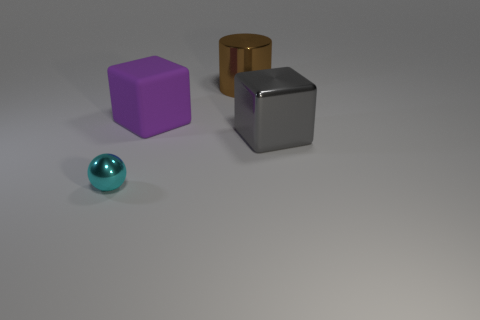Add 3 green rubber balls. How many objects exist? 7 Subtract all tiny cyan metal objects. Subtract all tiny shiny objects. How many objects are left? 2 Add 2 gray blocks. How many gray blocks are left? 3 Add 1 cyan balls. How many cyan balls exist? 2 Subtract 0 cyan cylinders. How many objects are left? 4 Subtract all cylinders. How many objects are left? 3 Subtract all brown blocks. Subtract all gray spheres. How many blocks are left? 2 Subtract all brown balls. How many purple blocks are left? 1 